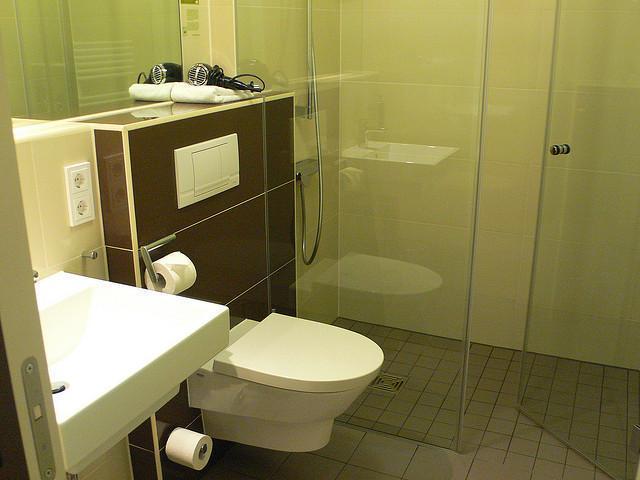How many toilets can you see?
Give a very brief answer. 2. How many zebra are in the picture?
Give a very brief answer. 0. 